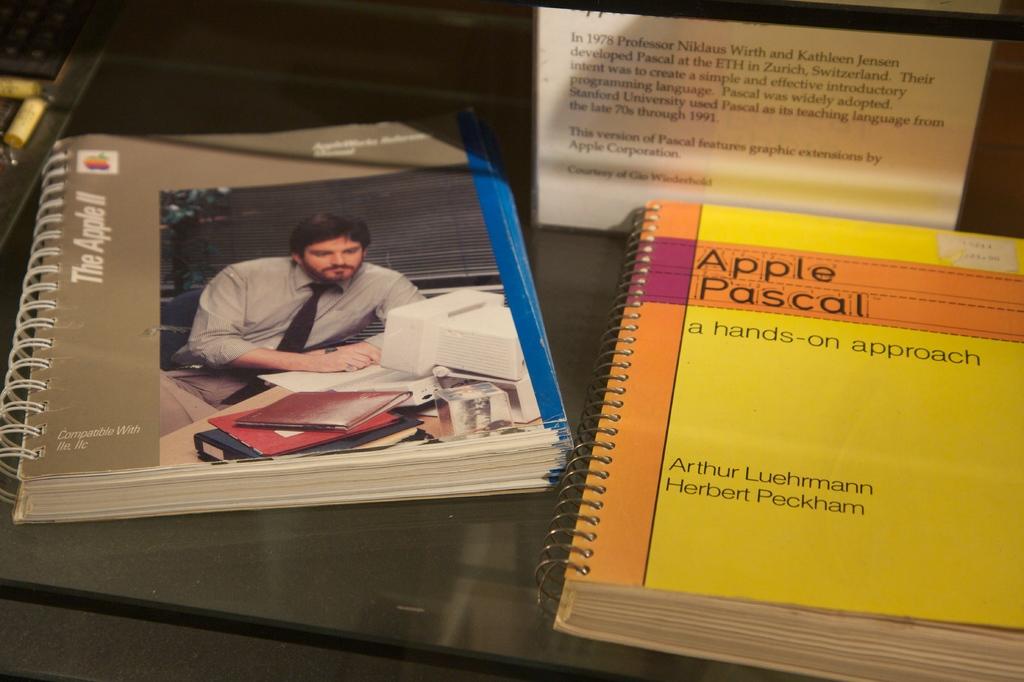What is the author name of the book?
Offer a very short reply. Arthur luehrmann. 